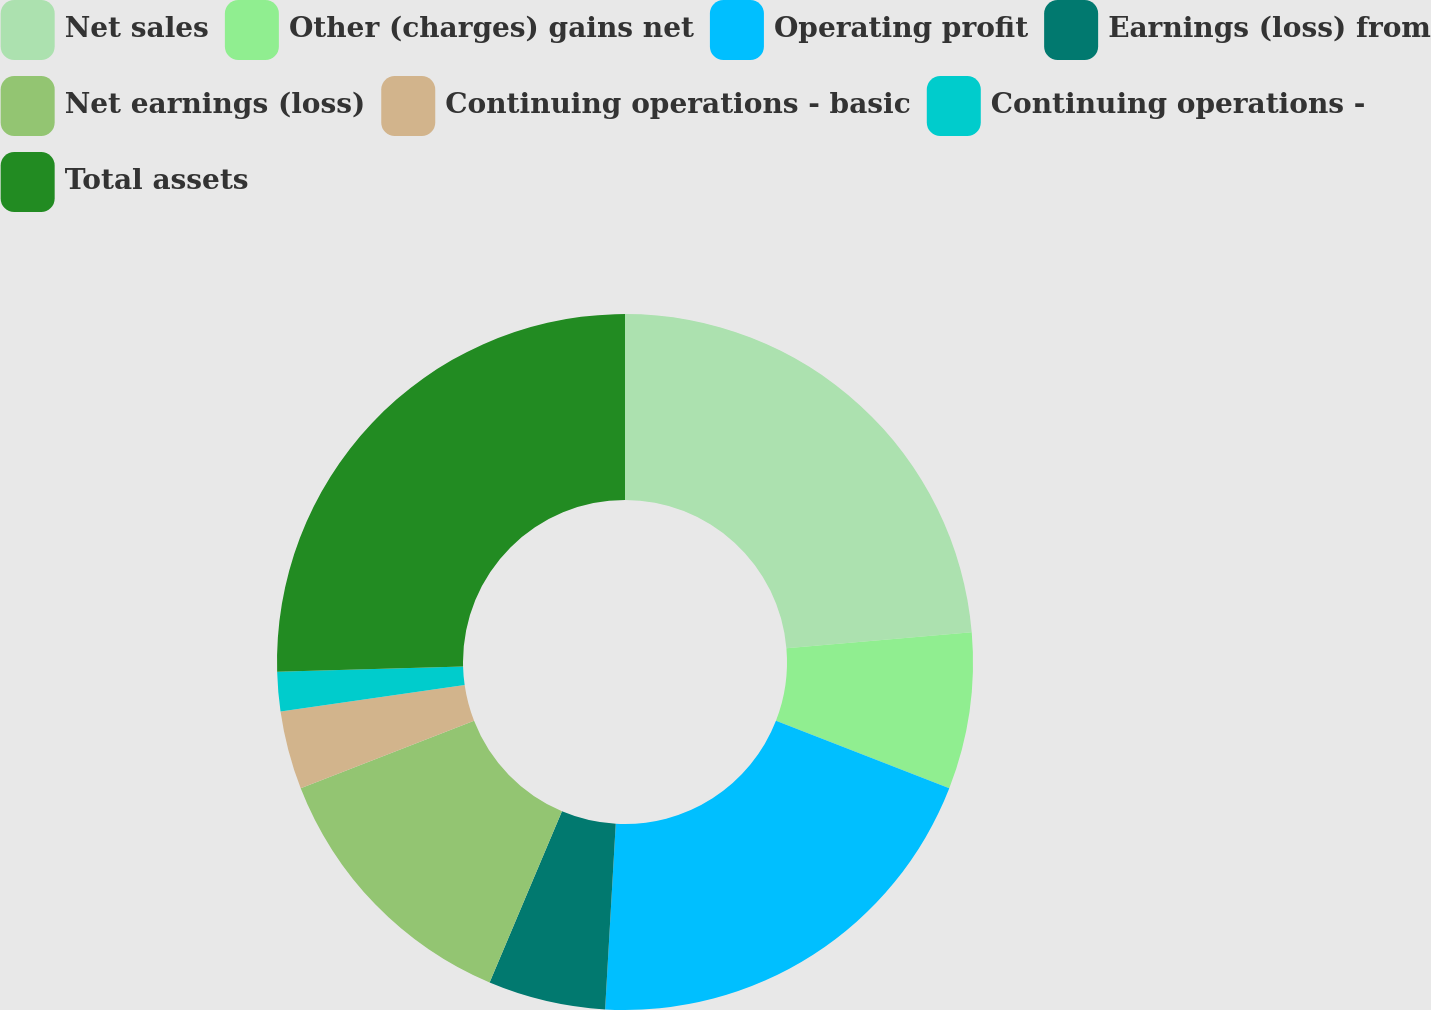<chart> <loc_0><loc_0><loc_500><loc_500><pie_chart><fcel>Net sales<fcel>Other (charges) gains net<fcel>Operating profit<fcel>Earnings (loss) from<fcel>Net earnings (loss)<fcel>Continuing operations - basic<fcel>Continuing operations -<fcel>Total assets<nl><fcel>23.64%<fcel>7.27%<fcel>20.0%<fcel>5.45%<fcel>12.73%<fcel>3.64%<fcel>1.82%<fcel>25.45%<nl></chart> 